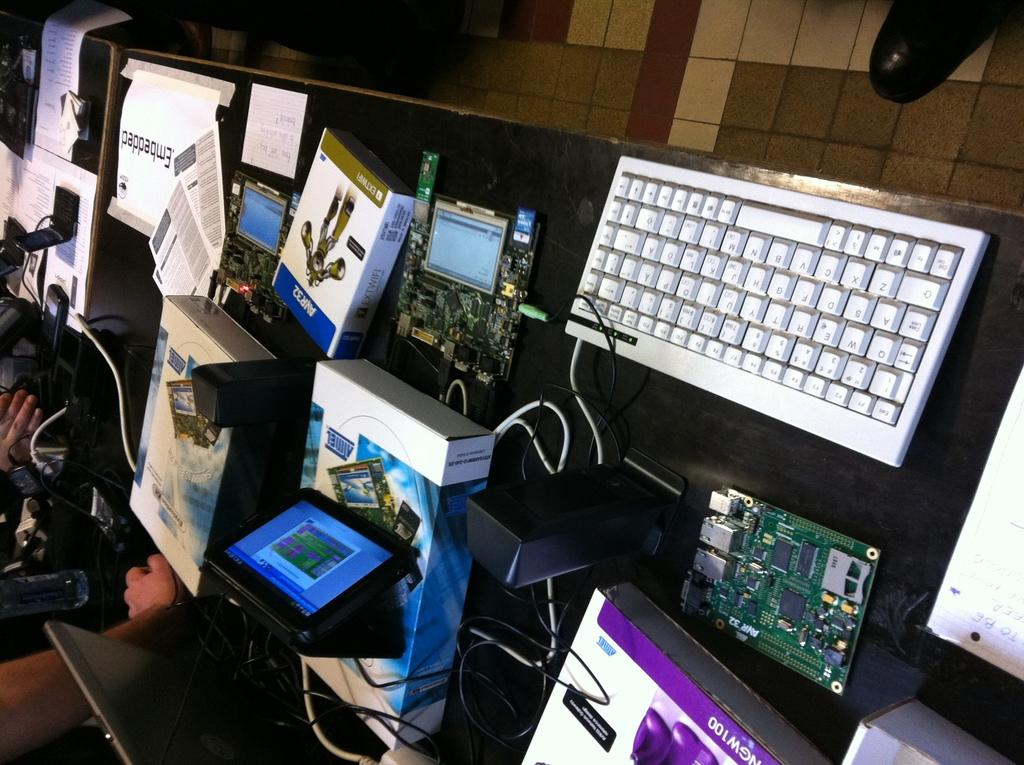<image>
Give a short and clear explanation of the subsequent image. A messy desk has many items scattered across it such as EXTWIFI. 